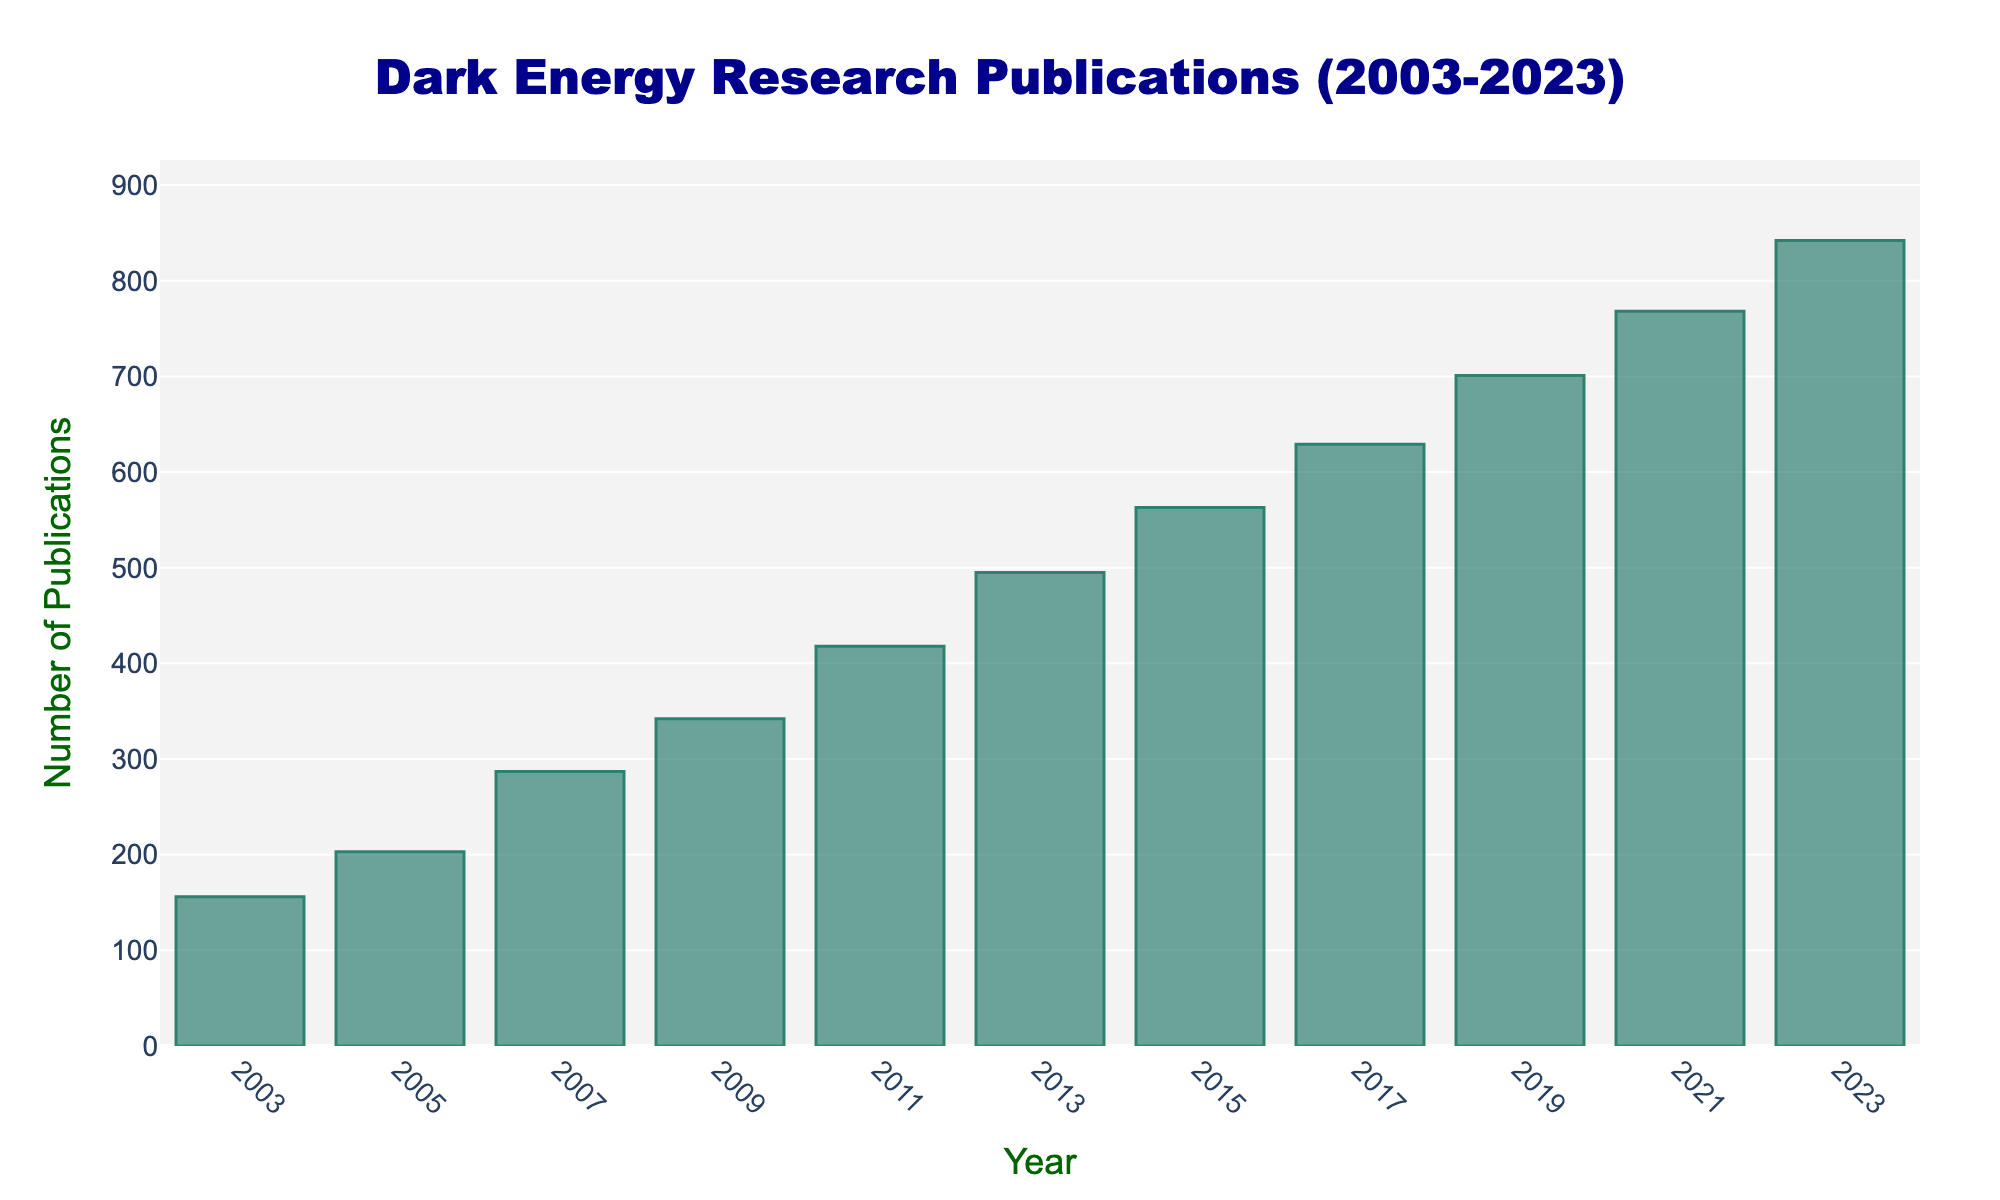What is the overall trend in the number of publications from 2003 to 2023? The bar chart shows a consistent increase in the number of publications on dark energy research from 2003 to 2023. Each consecutive year shows a higher bar compared to the previous one, indicating an upward trend.
Answer: Increasing Which year had the highest number of publications? The highest bar in the chart corresponds to the year 2023, indicating that this year had the highest number of publications.
Answer: 2023 By how many publications did the number increase from 2003 to 2023? The number of publications in 2003 was 156, and in 2023, it was 842. The increase can be calculated as 842 - 156 = 686.
Answer: 686 What is the average number of publications per year over the years 2003 to 2023? First, sum the number of publications for all years, then divide by the number of years (11). The total number of publications = 156 + 203 + 287 + 342 + 418 + 495 + 563 + 629 + 701 + 768 + 842 = 5404. Average = 5404 / 11 ≈ 491.27
Answer: ≈ 491 Which year saw the smallest increase in publications compared to the previous year? Comparing the differences between each consecutive year: 
2005 - 2003 = 47, 
2007 - 2005 = 84, 
2009 - 2007 = 55, 
2011 - 2009 = 76, 
2013 - 2011 = 77, 
2015 - 2013 = 68, 
2017 - 2015 = 66, 
2019 - 2017 = 72, 
2021 - 2019 = 67, 
2023 - 2021 = 74. The smallest difference is between 2009 and 2007, with an increase of only 55 publications.
Answer: 2009 Which year had roughly half the number of publications as compared to the year 2023? The number of publications in 2023 was 842. Half of this is approximately 421. The year 2011 had 418 publications, which is closest to this value.
Answer: 2011 What is the median number of publications over the two decades? To find the median, list the number of publications in ascending order and find the middle value. The ordered list is: 156, 203, 287, 342, 418, 495, 563, 629, 701, 768, 842. The median value, being the middle of this ordered list, is 495.
Answer: 495 Compare the number of publications in 2003 with 2013. How much did it increase by percentage? The number of publications in 2003 was 156, and in 2013, it was 495. To find the percentage increase: ((495 - 156) / 156) * 100 ≈ 217.31%.
Answer: ≈ 217.31% What is the general shape and color of the bars representing the publications? The bars are vertical and have a greenish color with a slightly transparent effect, and they are outlined with a darker green color.
Answer: Vertical, greenish 